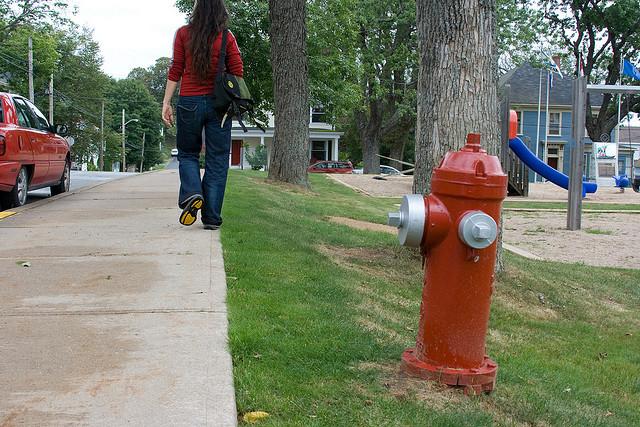How many kids playing in the playground?
Keep it brief. 0. What color is the woman's top?
Give a very brief answer. Red. Where is the woman going?
Answer briefly. Home. 